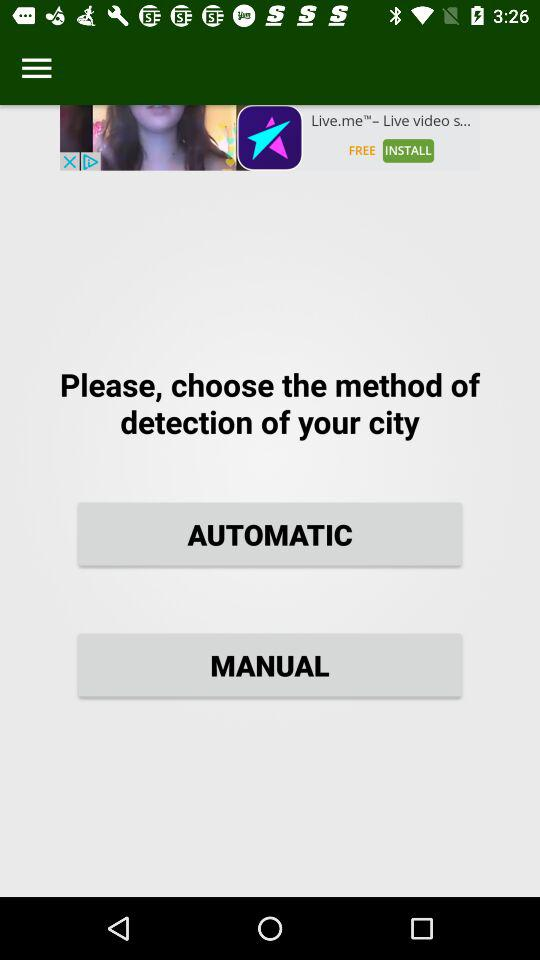What methods are available to detect the city? The methods that are available to detect the city are "AUTOMATIC" and "MANUAL". 